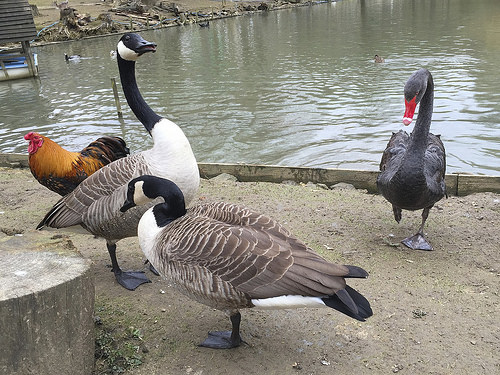<image>
Is there a hen in the lake? No. The hen is not contained within the lake. These objects have a different spatial relationship. 